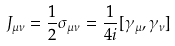<formula> <loc_0><loc_0><loc_500><loc_500>J _ { \mu \nu } = \frac { 1 } { 2 } \sigma _ { \mu \nu } = \frac { 1 } { 4 i } [ \gamma _ { \mu } , \gamma _ { \nu } ]</formula> 